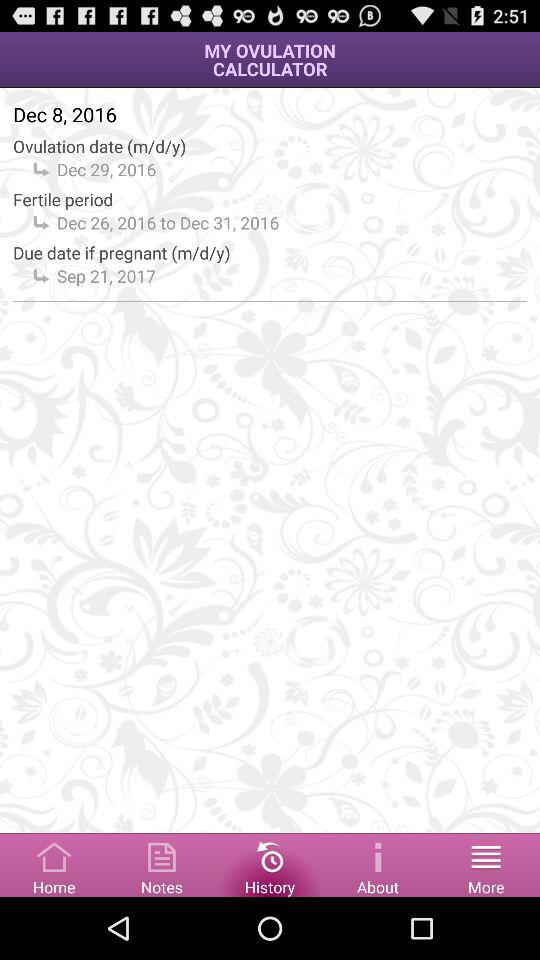What due date is given if pregnant? The given due date is September 21, 2017. 